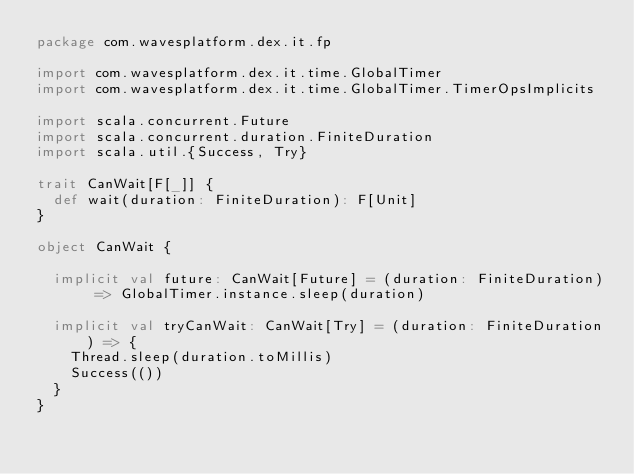Convert code to text. <code><loc_0><loc_0><loc_500><loc_500><_Scala_>package com.wavesplatform.dex.it.fp

import com.wavesplatform.dex.it.time.GlobalTimer
import com.wavesplatform.dex.it.time.GlobalTimer.TimerOpsImplicits

import scala.concurrent.Future
import scala.concurrent.duration.FiniteDuration
import scala.util.{Success, Try}

trait CanWait[F[_]] {
  def wait(duration: FiniteDuration): F[Unit]
}

object CanWait {

  implicit val future: CanWait[Future] = (duration: FiniteDuration) => GlobalTimer.instance.sleep(duration)

  implicit val tryCanWait: CanWait[Try] = (duration: FiniteDuration) => {
    Thread.sleep(duration.toMillis)
    Success(())
  }
}
</code> 